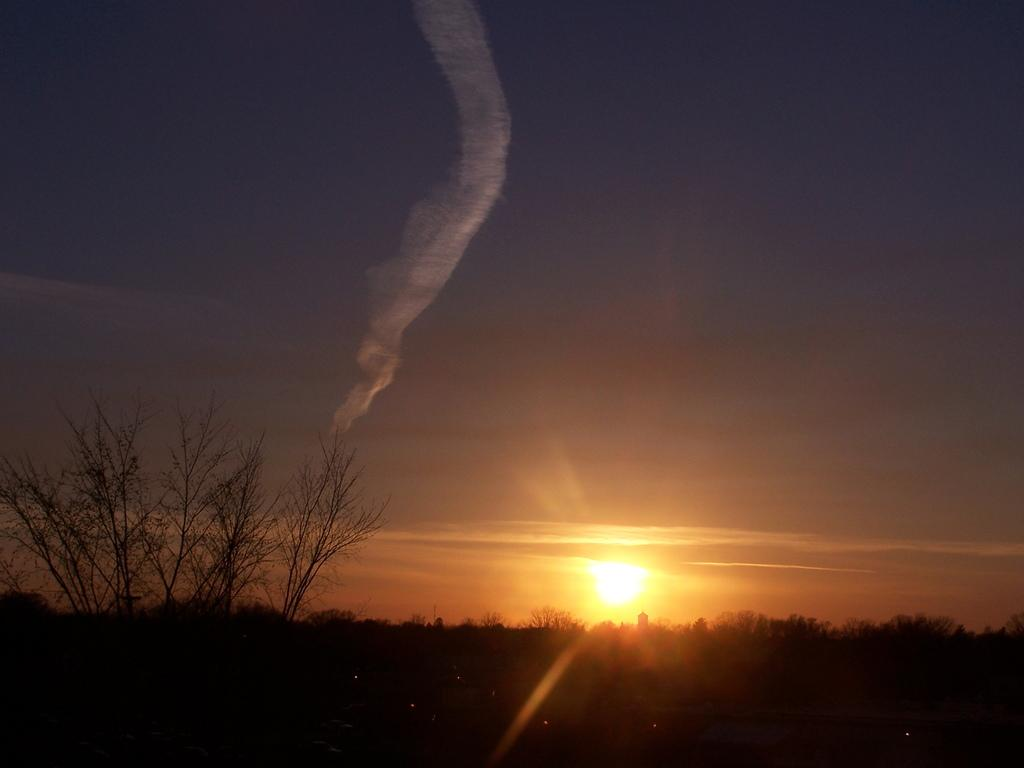What is visible in the center of the image? The sky, the sun, trees, and smoke are visible in the center of the image. Can you describe the celestial body visible in the center of the image? The sun is observable in the center of the image. What type of vegetation is visible in the center of the image? Trees are visible in the center of the image. What might be the source of the smoke visible in the center of the image? The source of the smoke is not explicitly mentioned in the provided facts. How many bombs can be seen in the image? There are no bombs present in the image. What type of can is visible in the image? There is no can visible in the image. 